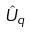<formula> <loc_0><loc_0><loc_500><loc_500>\hat { U } _ { q }</formula> 